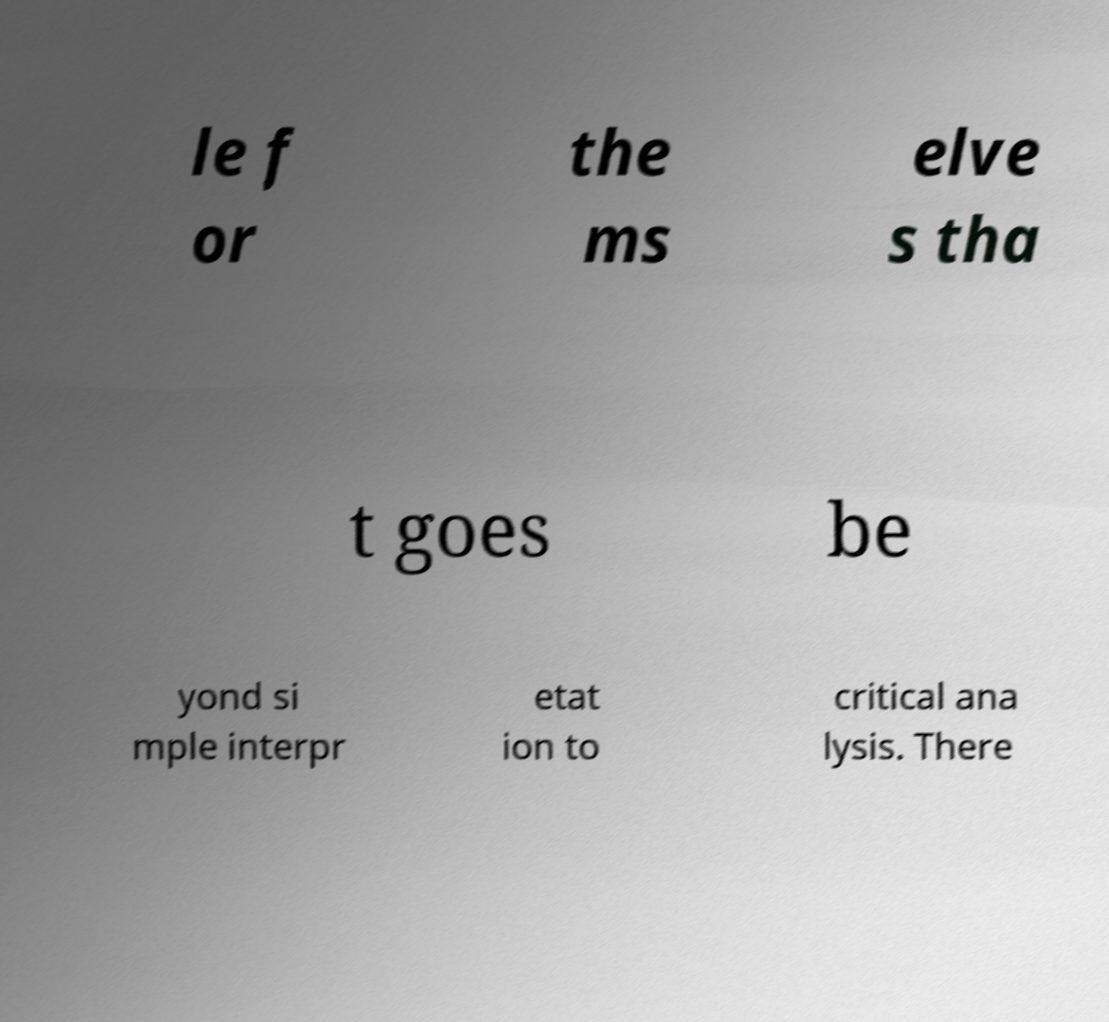There's text embedded in this image that I need extracted. Can you transcribe it verbatim? le f or the ms elve s tha t goes be yond si mple interpr etat ion to critical ana lysis. There 